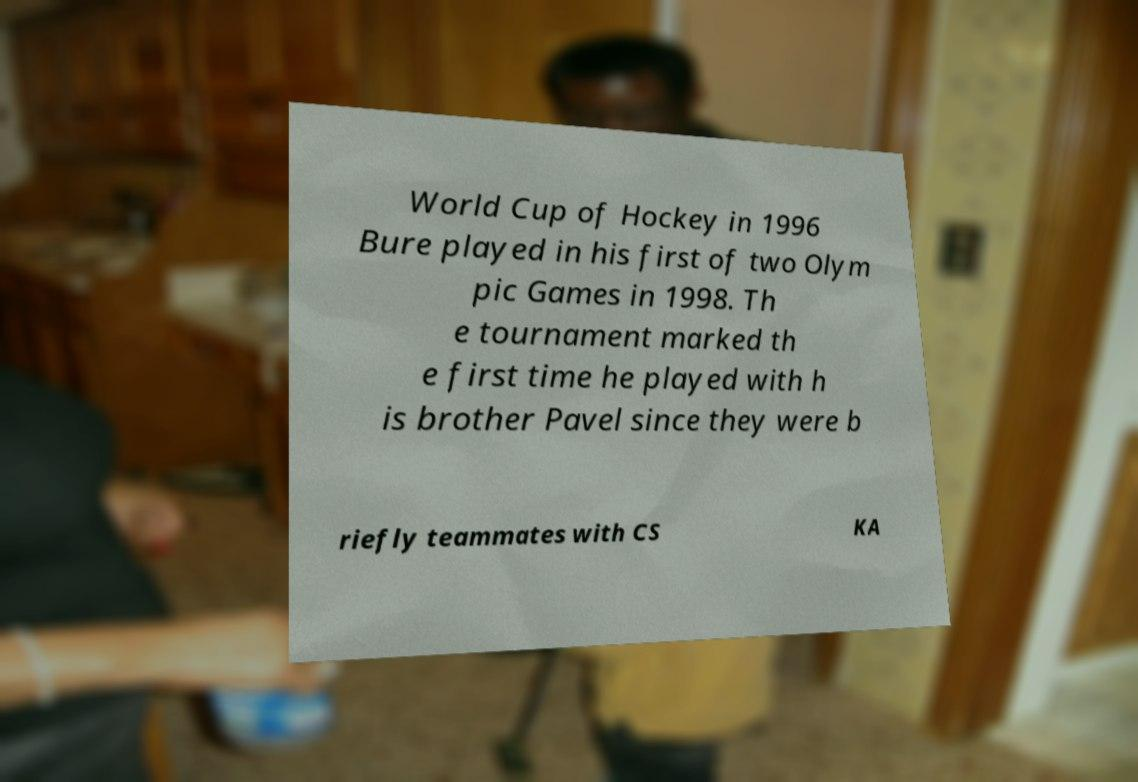Please read and relay the text visible in this image. What does it say? World Cup of Hockey in 1996 Bure played in his first of two Olym pic Games in 1998. Th e tournament marked th e first time he played with h is brother Pavel since they were b riefly teammates with CS KA 